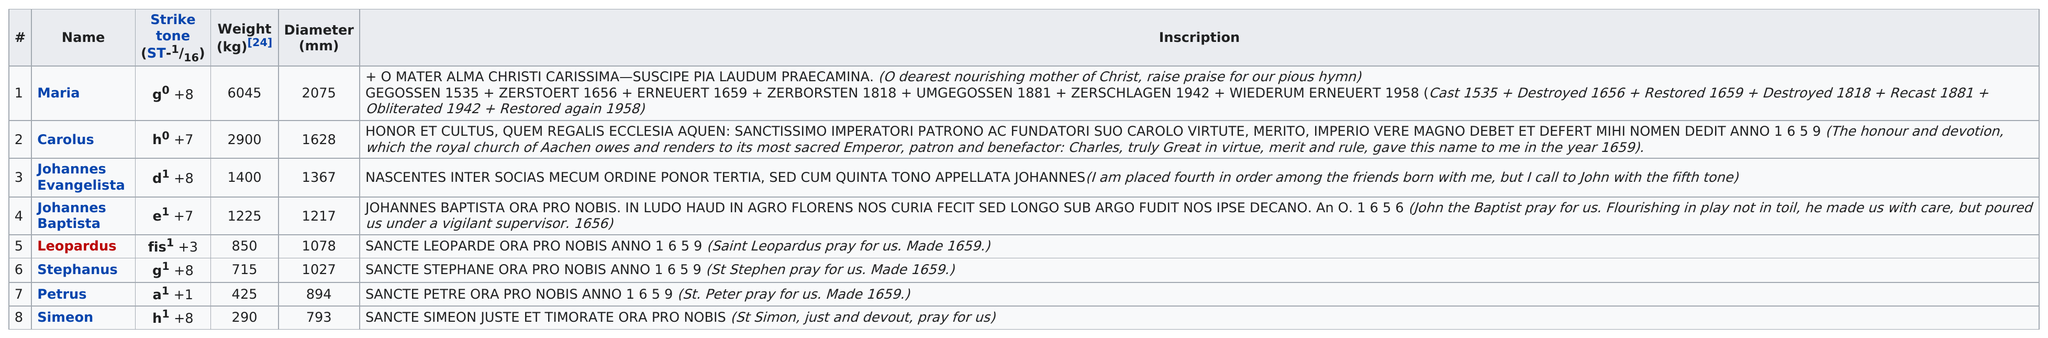Give some essential details in this illustration. The diameter of the smallest bell is approximately 793... The bell with the largest diameter is called Maria. The heaviest bell is named Maria. Four bells that weigh less than 1000 kg each. The bell with a weight of only 425 kg is named Petrus. 